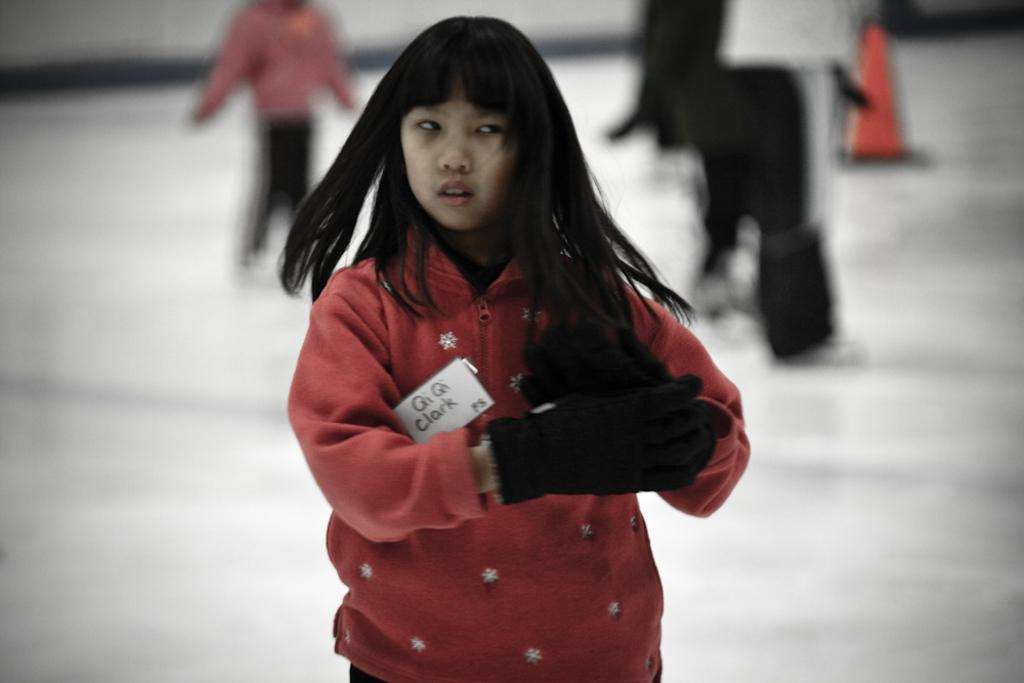Who is the main subject in the image? There is a girl in the image. What is the girl wearing? The girl is wearing a red jacket and black gloves. Can you describe the people in the background of the image? There are people standing in the background of the image. What is the color of the surface they are standing on? The surface they are standing on is white in color. What time does the clock show in the image? There is no clock present in the image. How does the girl use the comb in the image? There is no comb present in the image. 